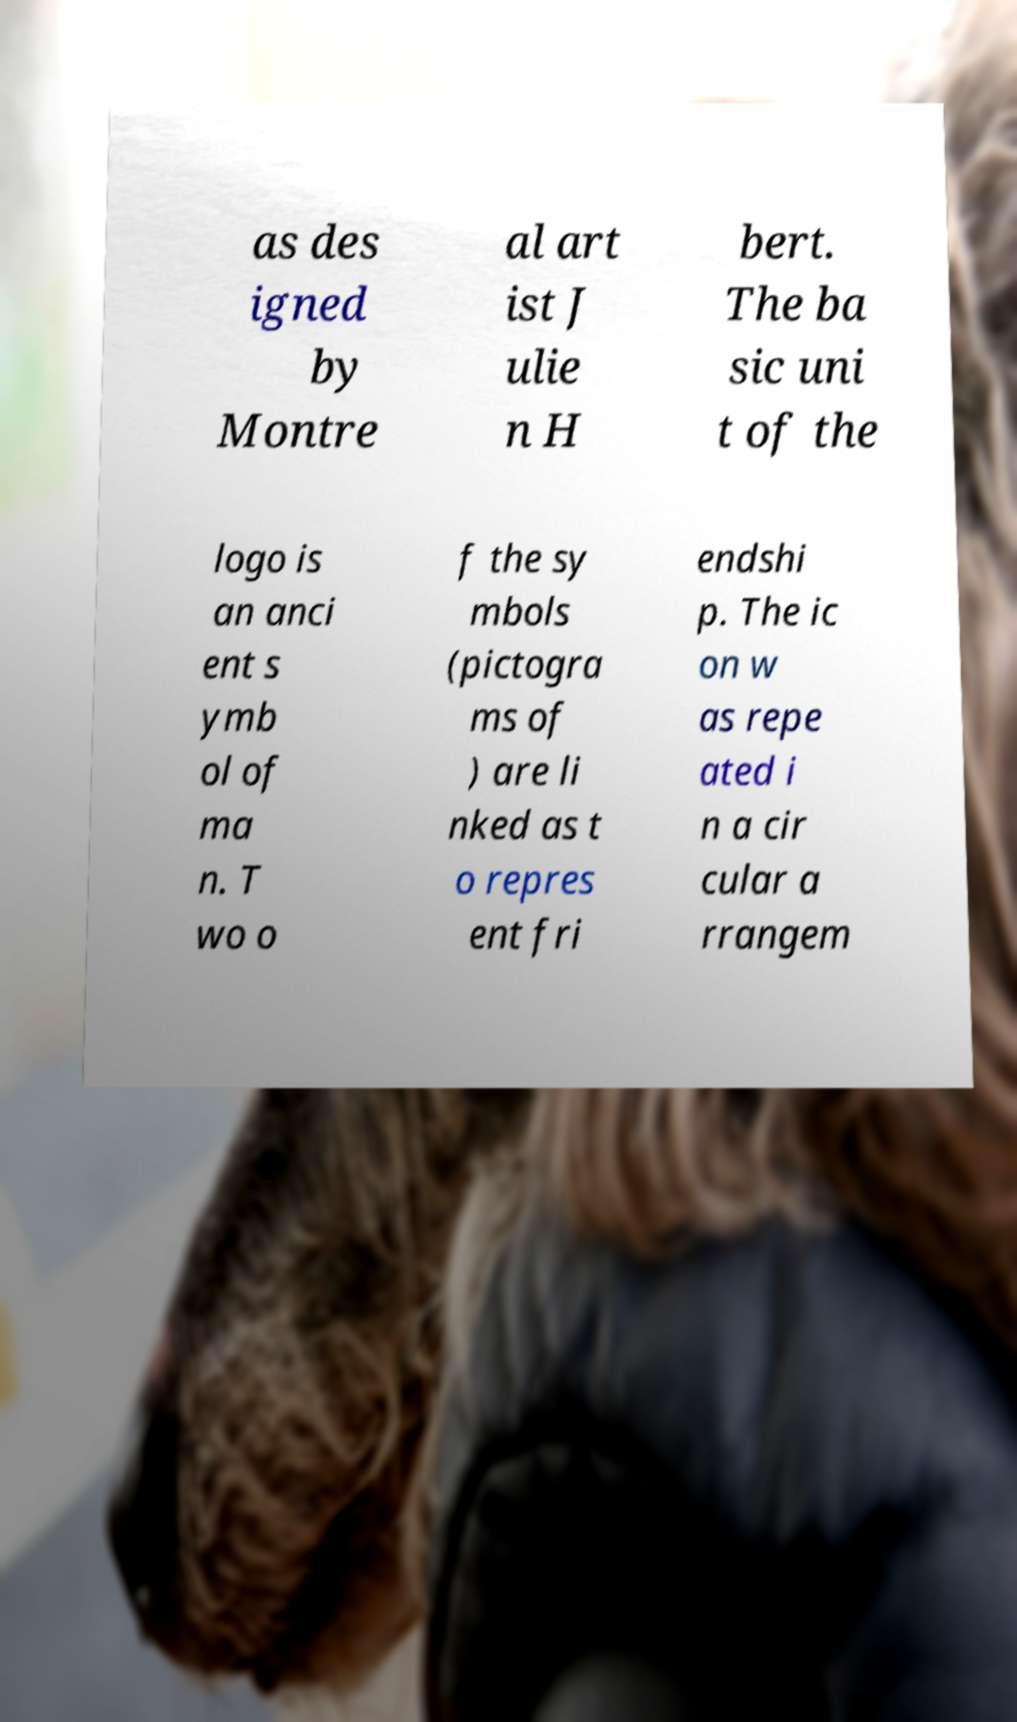Can you read and provide the text displayed in the image?This photo seems to have some interesting text. Can you extract and type it out for me? as des igned by Montre al art ist J ulie n H bert. The ba sic uni t of the logo is an anci ent s ymb ol of ma n. T wo o f the sy mbols (pictogra ms of ) are li nked as t o repres ent fri endshi p. The ic on w as repe ated i n a cir cular a rrangem 